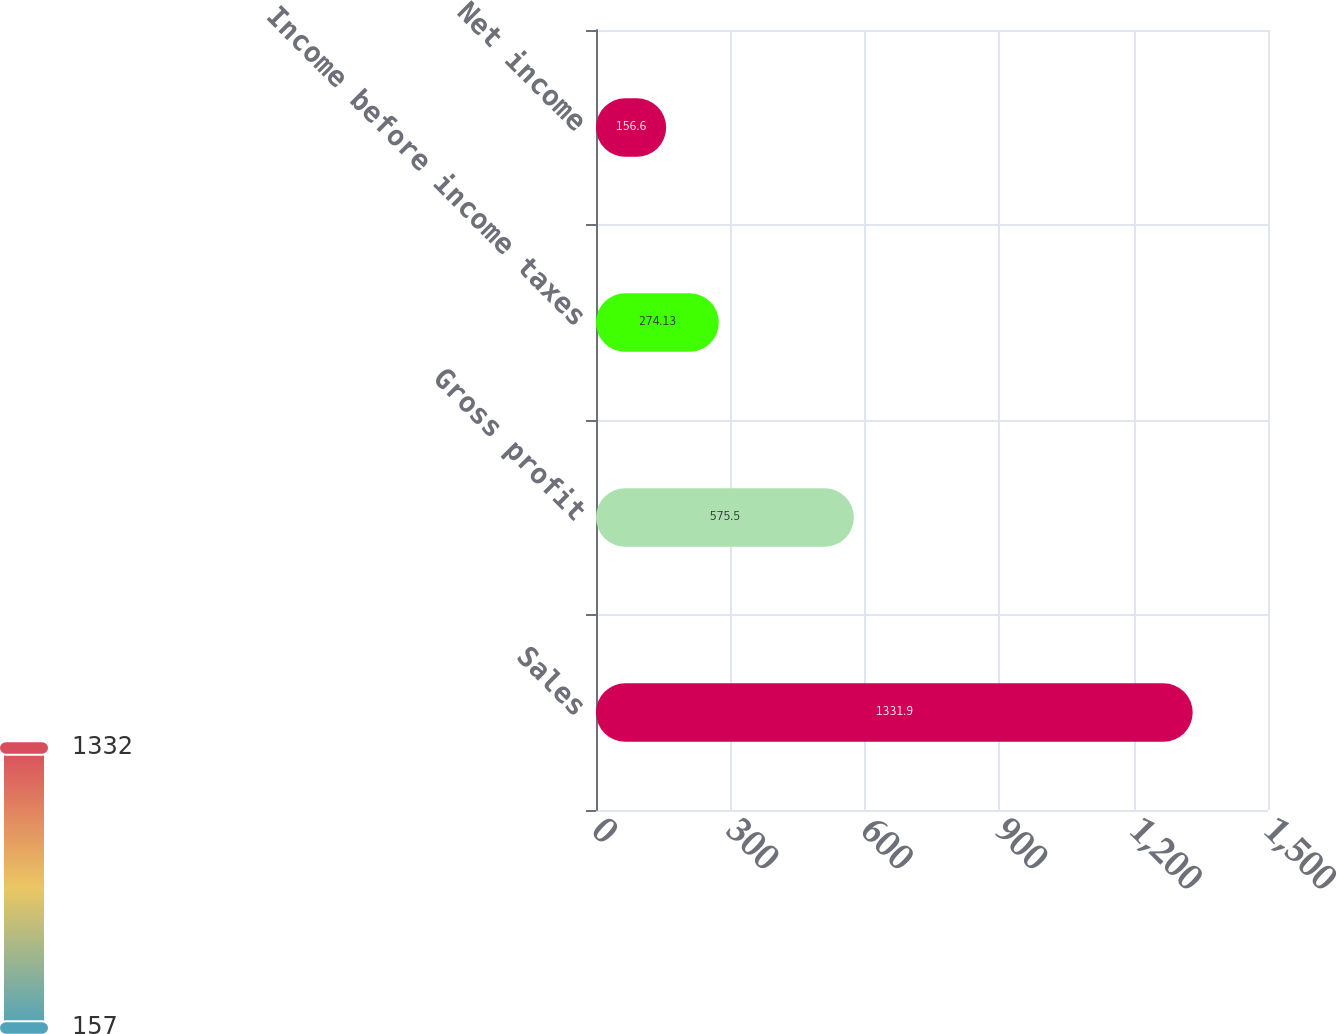Convert chart to OTSL. <chart><loc_0><loc_0><loc_500><loc_500><bar_chart><fcel>Sales<fcel>Gross profit<fcel>Income before income taxes<fcel>Net income<nl><fcel>1331.9<fcel>575.5<fcel>274.13<fcel>156.6<nl></chart> 